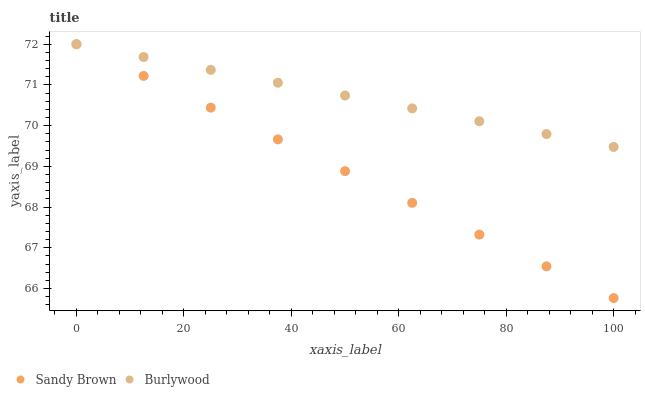Does Sandy Brown have the minimum area under the curve?
Answer yes or no. Yes. Does Burlywood have the maximum area under the curve?
Answer yes or no. Yes. Does Sandy Brown have the maximum area under the curve?
Answer yes or no. No. Is Burlywood the smoothest?
Answer yes or no. Yes. Is Sandy Brown the roughest?
Answer yes or no. Yes. Is Sandy Brown the smoothest?
Answer yes or no. No. Does Sandy Brown have the lowest value?
Answer yes or no. Yes. Does Sandy Brown have the highest value?
Answer yes or no. Yes. Does Burlywood intersect Sandy Brown?
Answer yes or no. Yes. Is Burlywood less than Sandy Brown?
Answer yes or no. No. Is Burlywood greater than Sandy Brown?
Answer yes or no. No. 